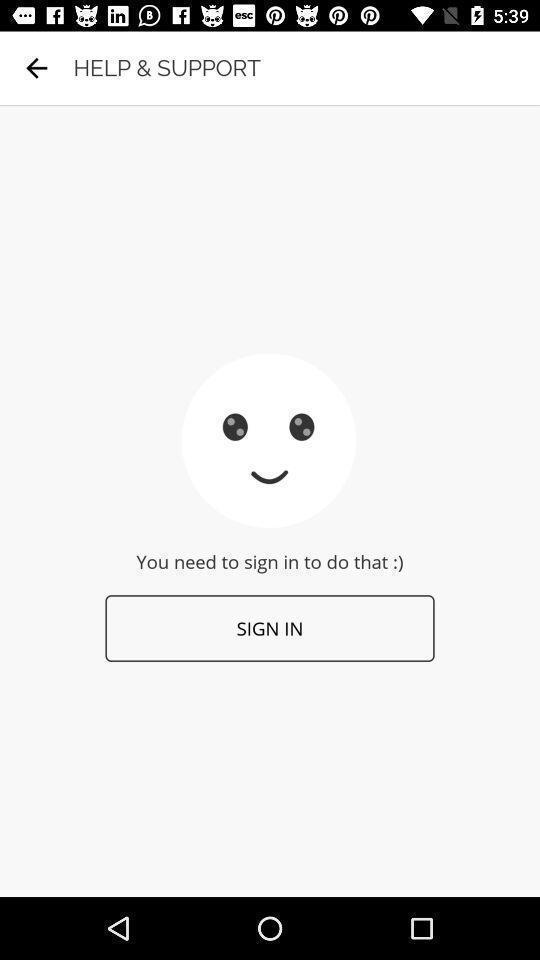Describe the key features of this screenshot. Sign in page. 